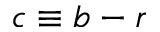<formula> <loc_0><loc_0><loc_500><loc_500>c \equiv b - r</formula> 